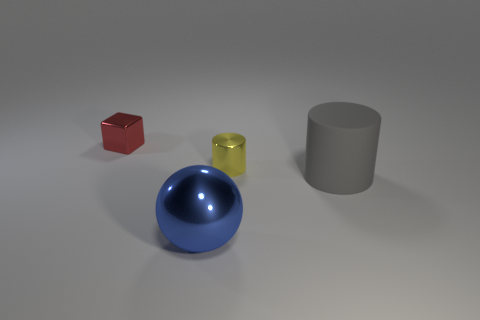Add 3 big matte objects. How many objects exist? 7 Subtract all spheres. How many objects are left? 3 Add 4 small red blocks. How many small red blocks are left? 5 Add 3 tiny cylinders. How many tiny cylinders exist? 4 Subtract 0 purple cylinders. How many objects are left? 4 Subtract all green cylinders. Subtract all brown balls. How many cylinders are left? 2 Subtract all shiny balls. Subtract all big metallic balls. How many objects are left? 2 